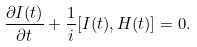<formula> <loc_0><loc_0><loc_500><loc_500>\frac { \partial I ( t ) } { \partial t } + \frac { 1 } { i } [ I ( t ) , H ( t ) ] = 0 .</formula> 